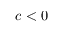<formula> <loc_0><loc_0><loc_500><loc_500>c < 0</formula> 